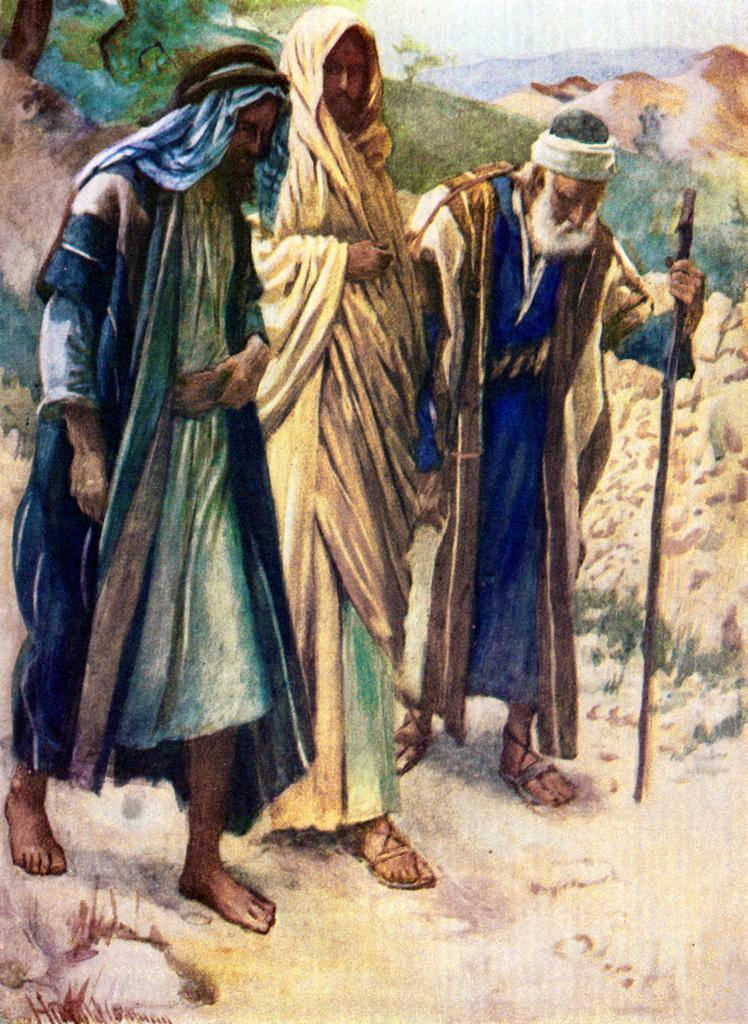What is the main subject of the image? The image contains a painting. What is depicted in the painting? The painting depicts three men. What are the men doing in the painting? The men are walking on the ground. What can be seen in the background of the painting? There is mud and trees visible in the background of the painting. What type of bun is being held by one of the men in the painting? There is no bun present in the painting; the men are walking on the ground. 